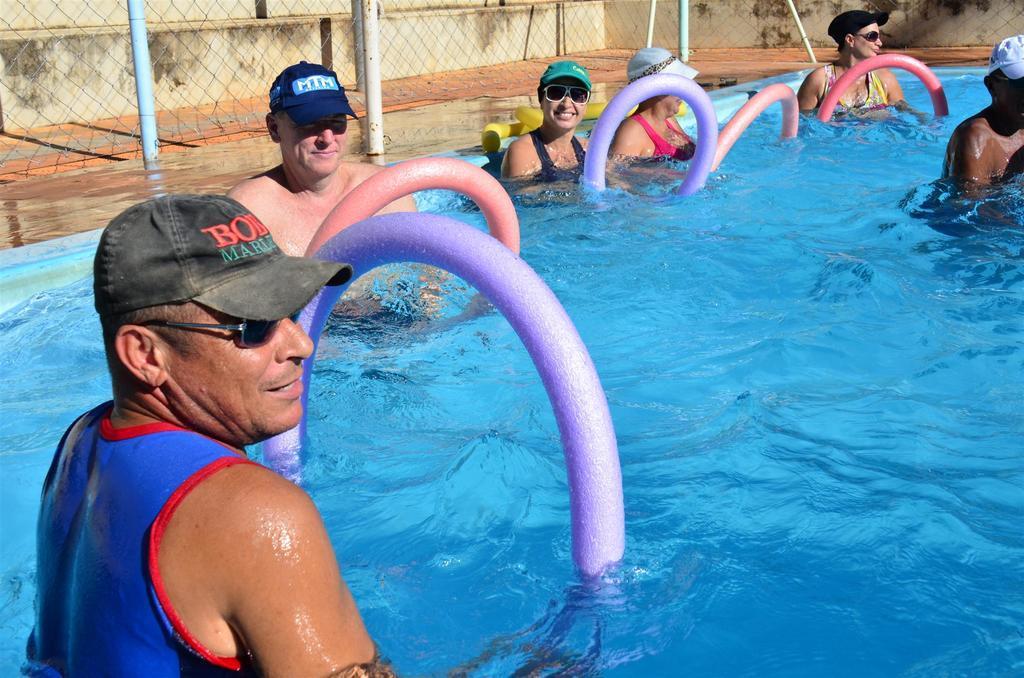Can you describe this image briefly? In this picture we can see a few people in water. There are some colorful objects in water. There is a fencing, poles and a wall in the background. 